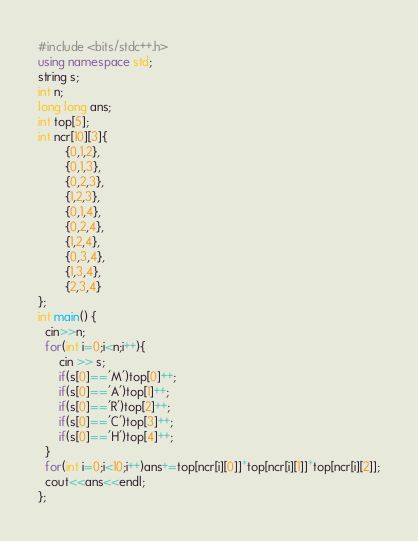<code> <loc_0><loc_0><loc_500><loc_500><_C++_>#include <bits/stdc++.h>
using namespace std;
string s;
int n;
long long ans;
int top[5];
int ncr[10][3]{
        {0,1,2},
        {0,1,3},
        {0,2,3},
        {1,2,3},
        {0,1,4},
        {0,2,4},
        {1,2,4},
        {0,3,4},
        {1,3,4},
        {2,3,4}
};
int main() {
  cin>>n;
  for(int i=0;i<n;i++){
      cin >> s;
      if(s[0]=='M')top[0]++;
      if(s[0]=='A')top[1]++;
      if(s[0]=='R')top[2]++;
      if(s[0]=='C')top[3]++;
      if(s[0]=='H')top[4]++;
  }
  for(int i=0;i<10;i++)ans+=top[ncr[i][0]]*top[ncr[i][1]]*top[ncr[i][2]];
  cout<<ans<<endl;
};</code> 